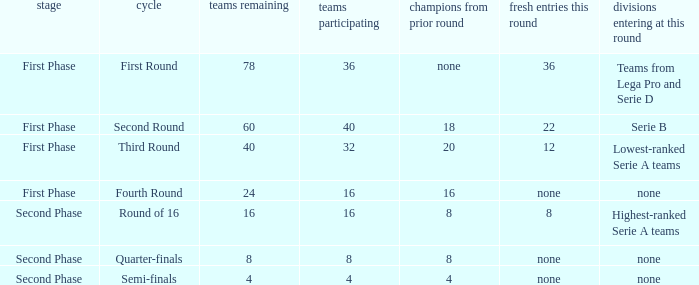During the first phase portion of phase and having 16 clubs involved; what would you find for the winners from previous round? 16.0. 